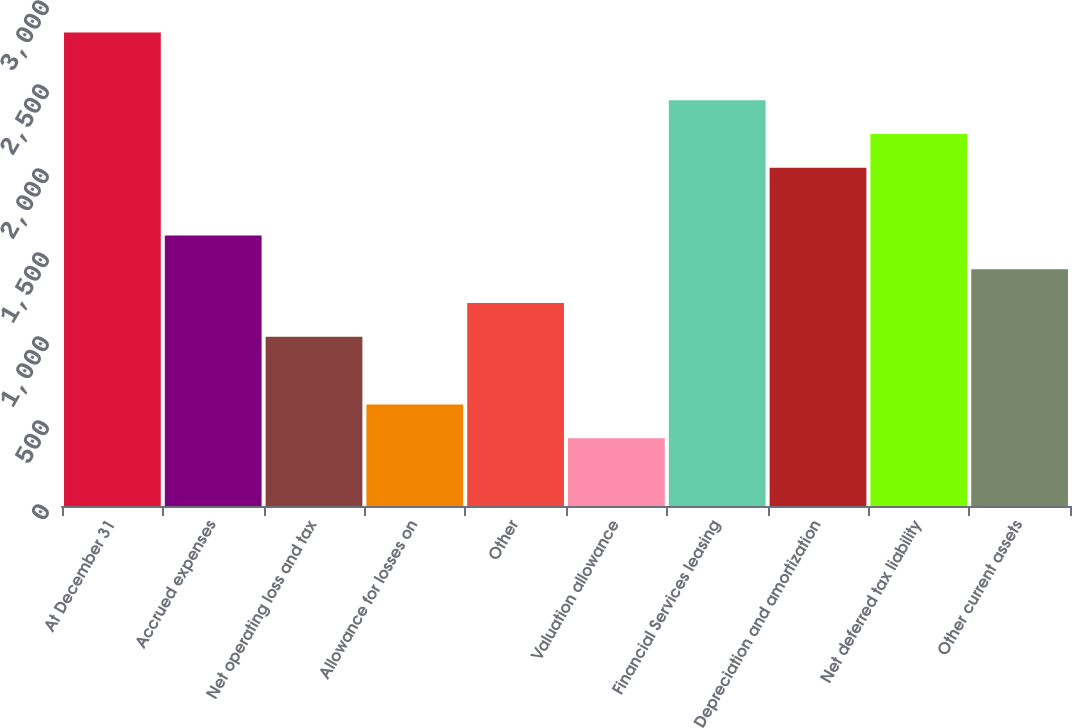Convert chart. <chart><loc_0><loc_0><loc_500><loc_500><bar_chart><fcel>At December 31<fcel>Accrued expenses<fcel>Net operating loss and tax<fcel>Allowance for losses on<fcel>Other<fcel>Valuation allowance<fcel>Financial Services leasing<fcel>Depreciation and amortization<fcel>Net deferred tax liability<fcel>Other current assets<nl><fcel>2817.96<fcel>1610.52<fcel>1006.8<fcel>604.32<fcel>1208.04<fcel>403.08<fcel>2415.48<fcel>2013<fcel>2214.24<fcel>1409.28<nl></chart> 